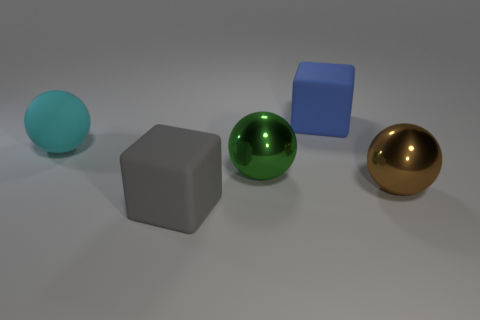Add 5 cyan balls. How many objects exist? 10 Subtract all cubes. How many objects are left? 3 Subtract all large green metal things. Subtract all blocks. How many objects are left? 2 Add 5 rubber blocks. How many rubber blocks are left? 7 Add 1 cyan cylinders. How many cyan cylinders exist? 1 Subtract 0 purple spheres. How many objects are left? 5 